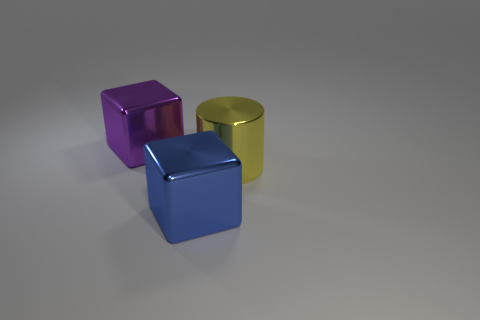Is the number of purple metal blocks that are on the right side of the yellow metal thing greater than the number of tiny blue metallic blocks?
Provide a short and direct response. No. Are there any blue metal cubes that are behind the metallic block in front of the shiny cube that is behind the blue shiny cube?
Your answer should be compact. No. There is a big purple block; are there any yellow objects in front of it?
Give a very brief answer. Yes. How many large cubes are the same color as the large cylinder?
Your answer should be compact. 0. The yellow thing that is made of the same material as the large purple cube is what size?
Your answer should be very brief. Large. There is a metallic cube that is right of the big metal block that is behind the large metallic block in front of the big yellow cylinder; what is its size?
Ensure brevity in your answer.  Large. There is a block left of the blue shiny thing; how big is it?
Your response must be concise. Large. What number of cyan objects are either tiny balls or shiny cylinders?
Provide a succinct answer. 0. Are there any purple metallic things of the same size as the yellow cylinder?
Offer a very short reply. Yes. What material is the blue cube that is the same size as the yellow shiny cylinder?
Offer a very short reply. Metal. 